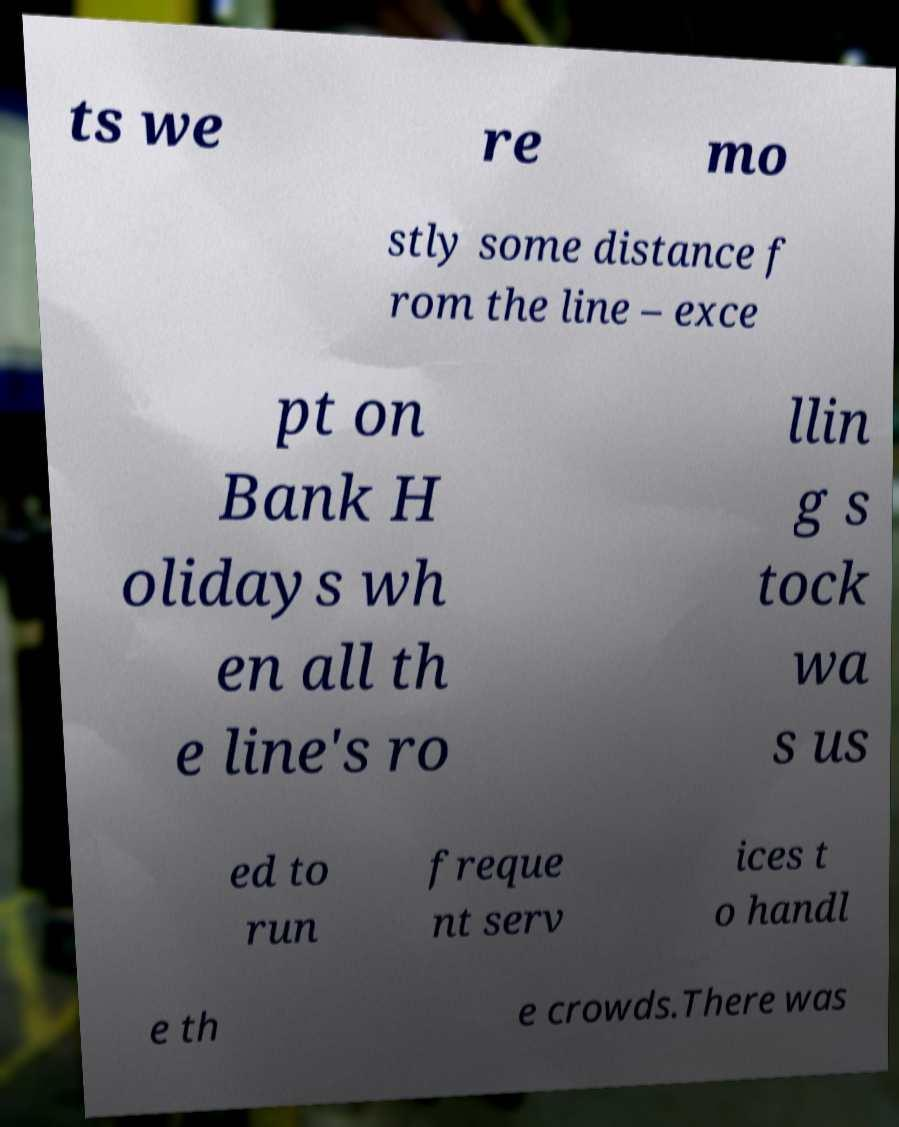Could you assist in decoding the text presented in this image and type it out clearly? ts we re mo stly some distance f rom the line – exce pt on Bank H olidays wh en all th e line's ro llin g s tock wa s us ed to run freque nt serv ices t o handl e th e crowds.There was 